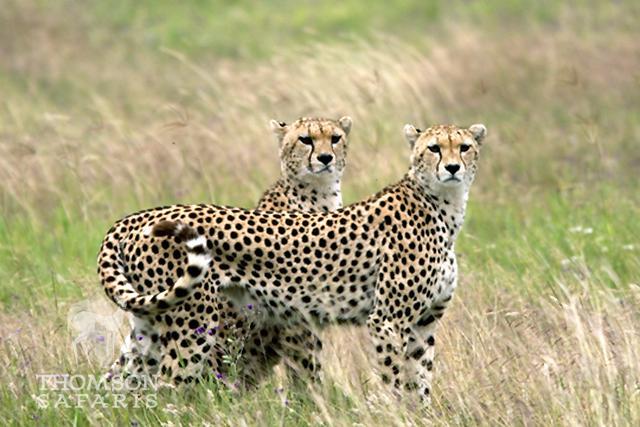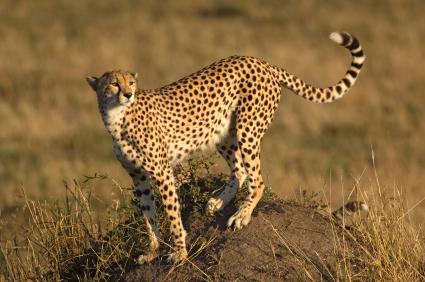The first image is the image on the left, the second image is the image on the right. Considering the images on both sides, is "The same number of cheetahs are present in the left and right images." valid? Answer yes or no. No. 